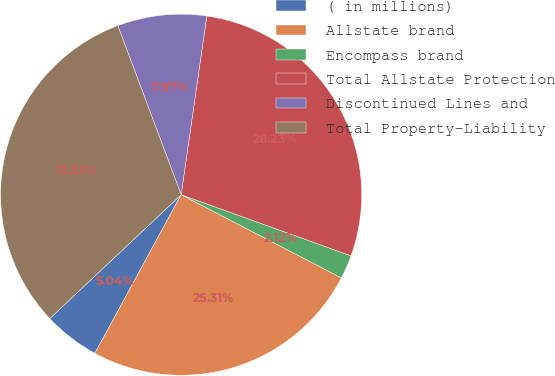<chart> <loc_0><loc_0><loc_500><loc_500><pie_chart><fcel>( in millions)<fcel>Allstate brand<fcel>Encompass brand<fcel>Total Allstate Protection<fcel>Discontinued Lines and<fcel>Total Property-Liability<nl><fcel>5.04%<fcel>25.31%<fcel>2.12%<fcel>28.23%<fcel>7.97%<fcel>31.33%<nl></chart> 